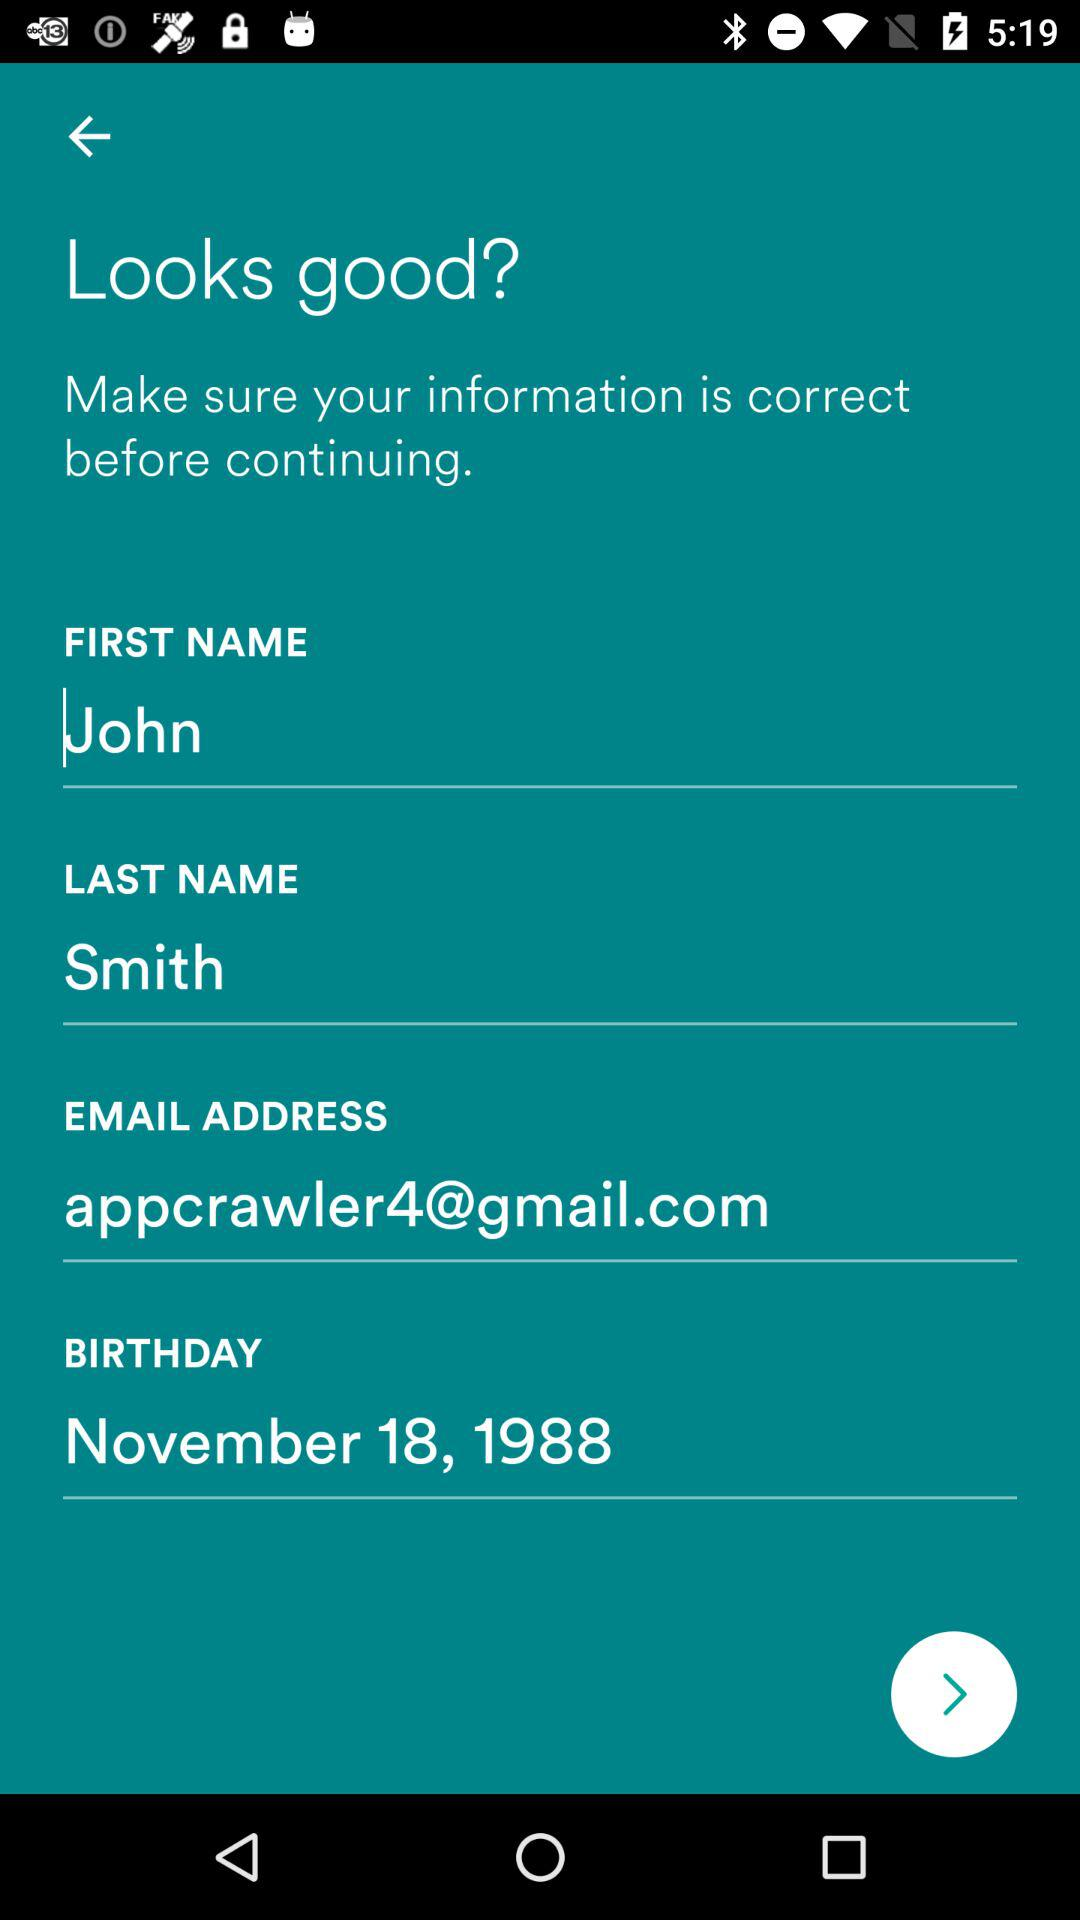What is the date of the birthday? The date of the birthday is November 18, 1988. 